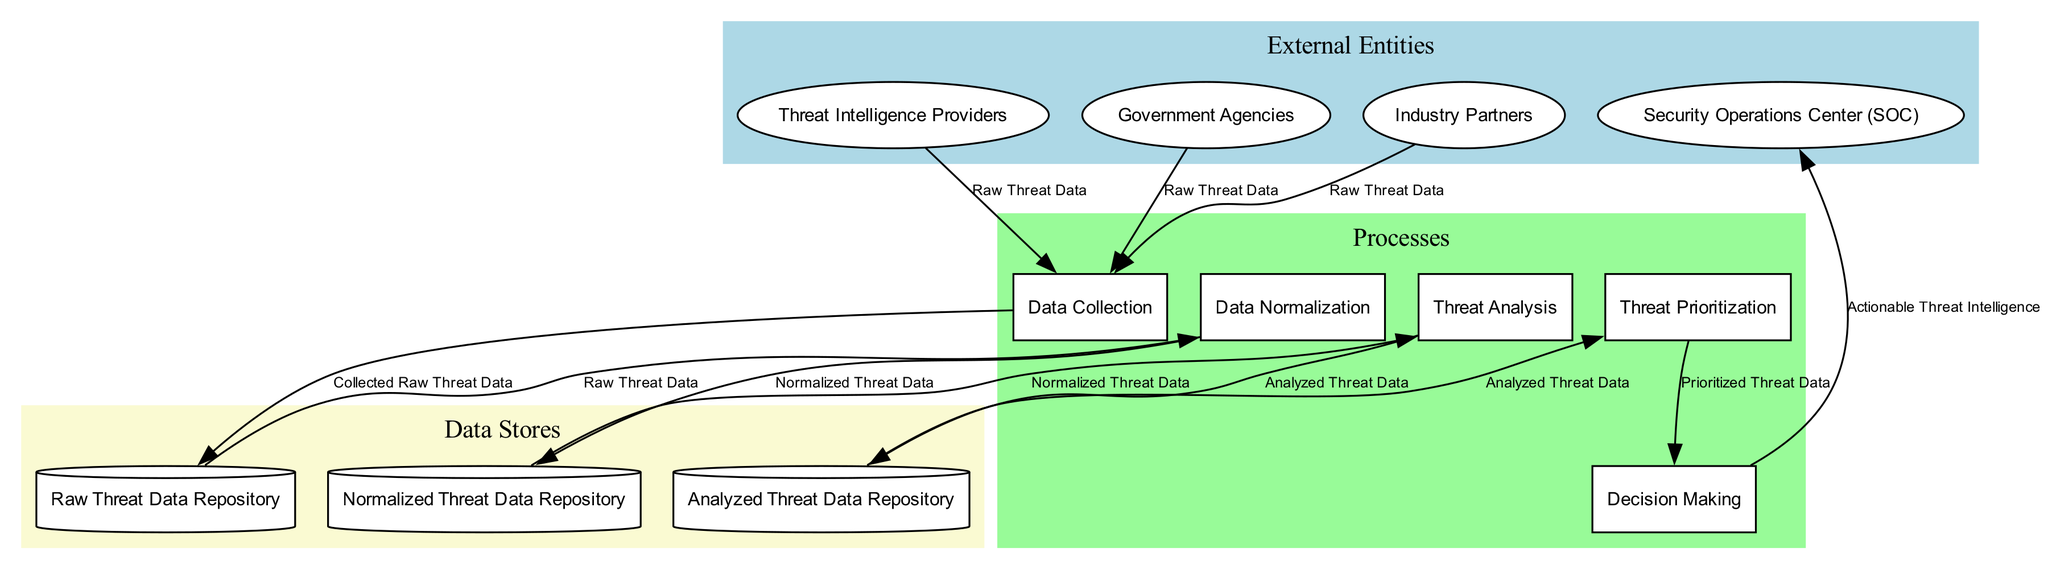What is the first external entity that provides data? The diagram shows multiple external entities; the first one listed is "Threat Intelligence Providers." Therefore, it is the first external entity that provides data.
Answer: Threat Intelligence Providers How many processes are involved in the diagram? The diagram includes five defined processes: Data Collection, Data Normalization, Threat Analysis, Threat Prioritization, and Decision Making. Counting these gives a total of five processes.
Answer: Five Which data store receives data from Data Normalization? According to the flow of data in the diagram, the "Normalized Threat Data Repository" receives data from "Data Normalization." This is indicated as the destination node linked to the normalization process.
Answer: Normalized Threat Data Repository What type of data flows from Threat Analysis to Analyzed Threat Data Repository? The data flowing from "Threat Analysis" to "Analyzed Threat Data Repository" is labeled as "Analyzed Threat Data" in the diagram. This denotes the specific data transfer between these two nodes in the data process.
Answer: Analyzed Threat Data Which external entity shares data last in the Data Collection process? By examining the data collection arrows, "Industry Partners" shares data last. This is determined by the order of the flows connecting external entities to the data collection process.
Answer: Industry Partners How many data stores are shown in the diagram? The diagram features three data stores: Raw Threat Data Repository, Normalized Threat Data Repository, and Analyzed Threat Data Repository. After identifying these, it confirms that there are three distinct data stores represented.
Answer: Three What is the final output of the process according to the diagram? The diagram specifies that the final output from the decision-making process is "Actionable Threat Intelligence," which reflects the ultimate outcome derived from the outlined processes and data flows.
Answer: Actionable Threat Intelligence Which process comes after Data Normalization? In the sequence of processes outlined in the diagram, "Threat Analysis" directly follows "Data Normalization," indicating the order of processing threat data as it moves through the system.
Answer: Threat Analysis What type of connection exists between Decision Making and Security Operations Center (SOC)? The connection between "Decision Making" and "Security Operations Center (SOC)" is defined as a data flow; specifically, this flow delivers "Actionable Threat Intelligence" as the data output from decision-making to the SOC.
Answer: Data flow 